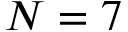<formula> <loc_0><loc_0><loc_500><loc_500>N = 7</formula> 